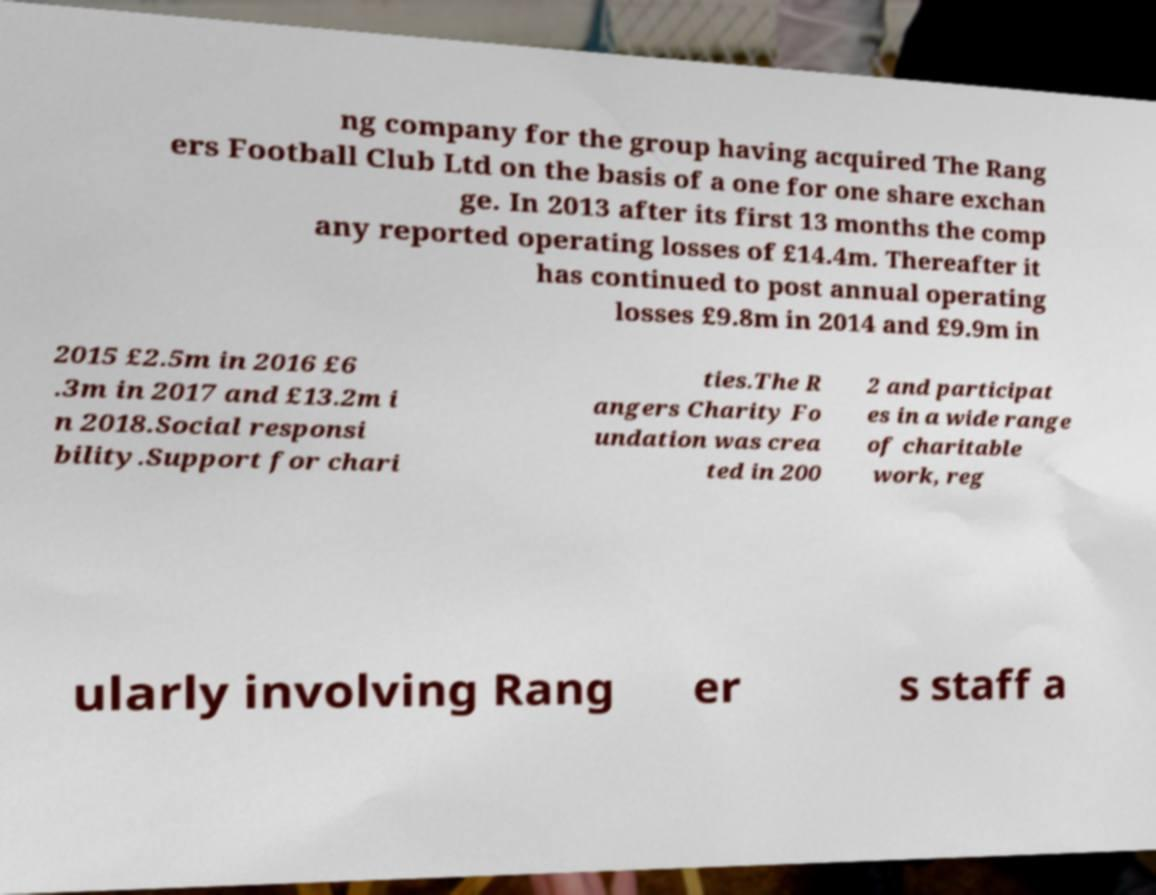For documentation purposes, I need the text within this image transcribed. Could you provide that? ng company for the group having acquired The Rang ers Football Club Ltd on the basis of a one for one share exchan ge. In 2013 after its first 13 months the comp any reported operating losses of £14.4m. Thereafter it has continued to post annual operating losses £9.8m in 2014 and £9.9m in 2015 £2.5m in 2016 £6 .3m in 2017 and £13.2m i n 2018.Social responsi bility.Support for chari ties.The R angers Charity Fo undation was crea ted in 200 2 and participat es in a wide range of charitable work, reg ularly involving Rang er s staff a 